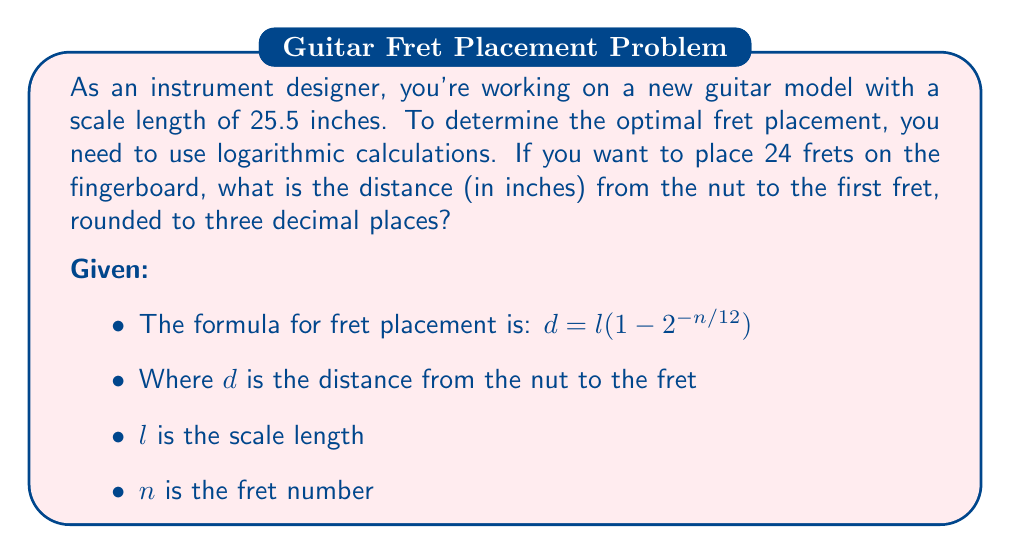Could you help me with this problem? To solve this problem, we'll use the given formula and the information provided:

1) The formula for fret placement is:
   $d = l(1 - 2^{-n/12})$

2) We know:
   - $l$ (scale length) = 25.5 inches
   - $n$ (fret number) = 1 (we're calculating the first fret)

3) Let's substitute these values into the formula:
   $d = 25.5(1 - 2^{-1/12})$

4) Now, let's calculate step by step:
   
   a) First, calculate $2^{-1/12}$:
      $2^{-1/12} \approx 0.9438743126816935$
   
   b) Then, subtract this value from 1:
      $1 - 0.9438743126816935 \approx 0.0561256873183065$
   
   c) Finally, multiply by the scale length:
      $25.5 * 0.0561256873183065 \approx 1.4312050266667158$

5) Rounding to three decimal places:
   $1.4312050266667158 \approx 1.431$ inches

Therefore, the distance from the nut to the first fret should be 1.431 inches.
Answer: 1.431 inches 